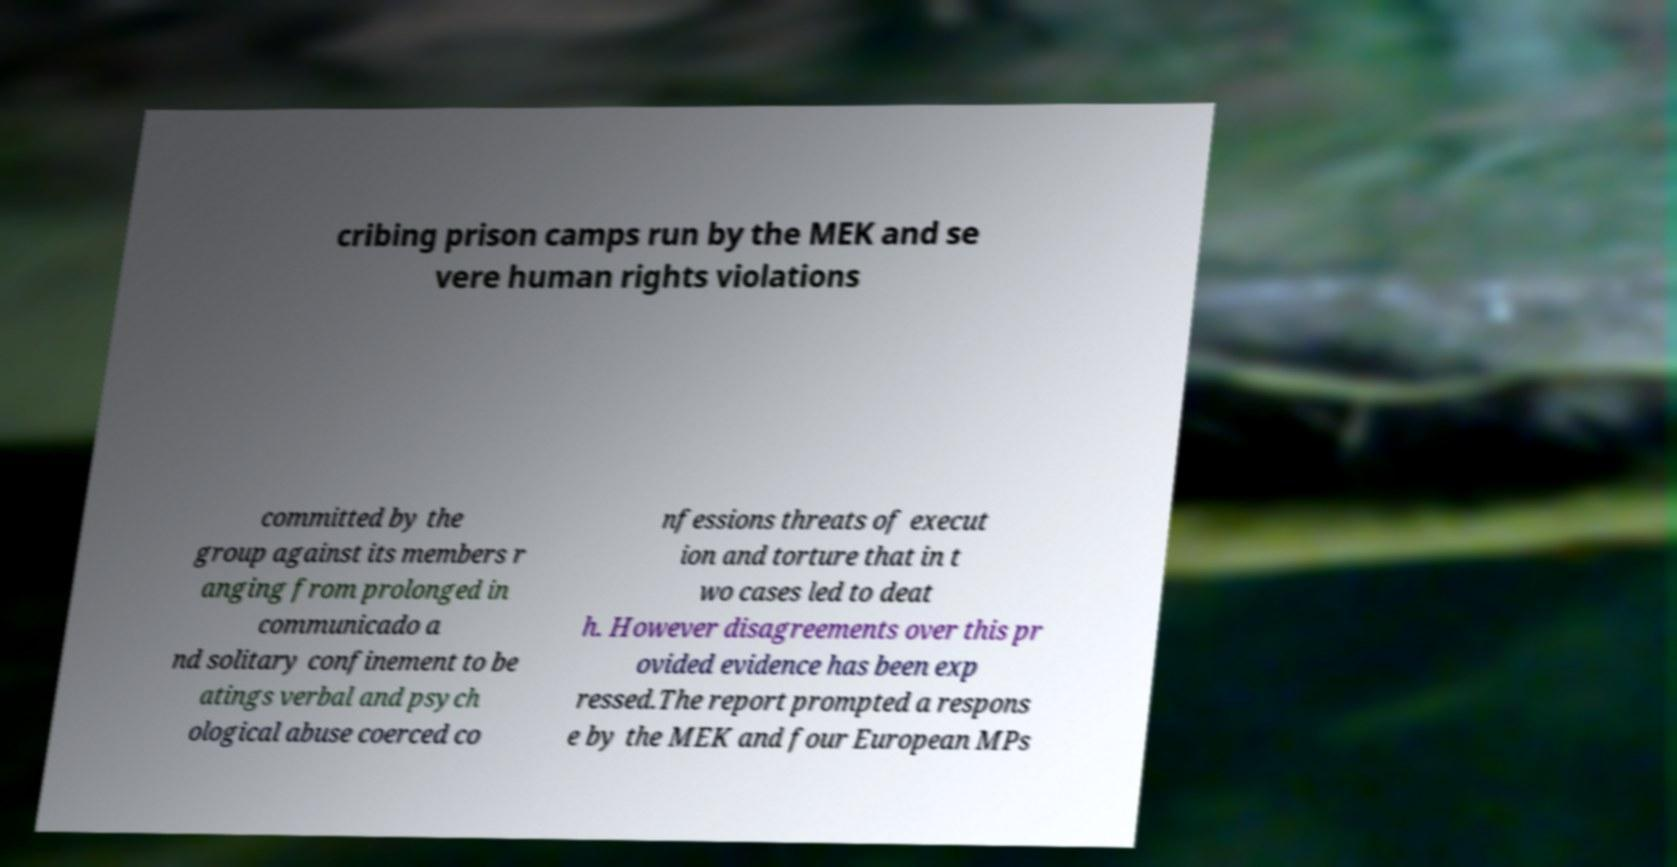Could you assist in decoding the text presented in this image and type it out clearly? cribing prison camps run by the MEK and se vere human rights violations committed by the group against its members r anging from prolonged in communicado a nd solitary confinement to be atings verbal and psych ological abuse coerced co nfessions threats of execut ion and torture that in t wo cases led to deat h. However disagreements over this pr ovided evidence has been exp ressed.The report prompted a respons e by the MEK and four European MPs 